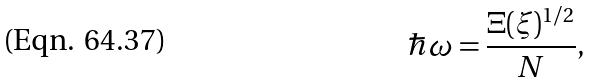<formula> <loc_0><loc_0><loc_500><loc_500>\hbar { \omega } = \frac { \Xi ( \xi ) ^ { 1 / 2 } } { N } ,</formula> 